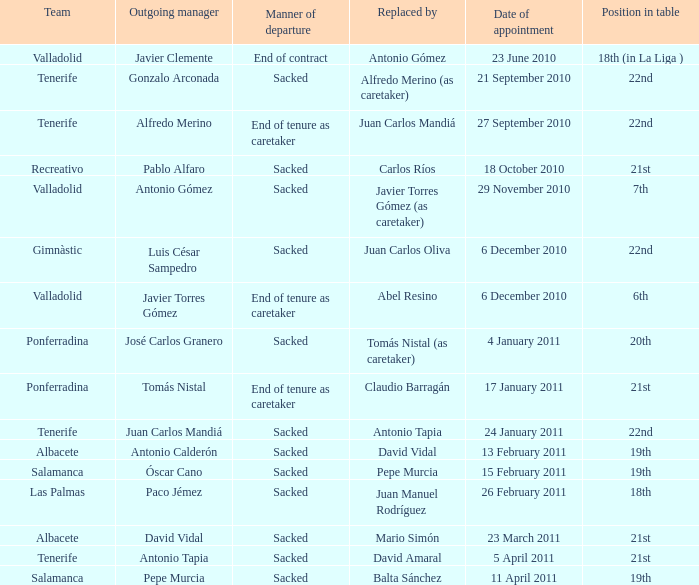What was the position of appointment date 17 january 2011 21st. 